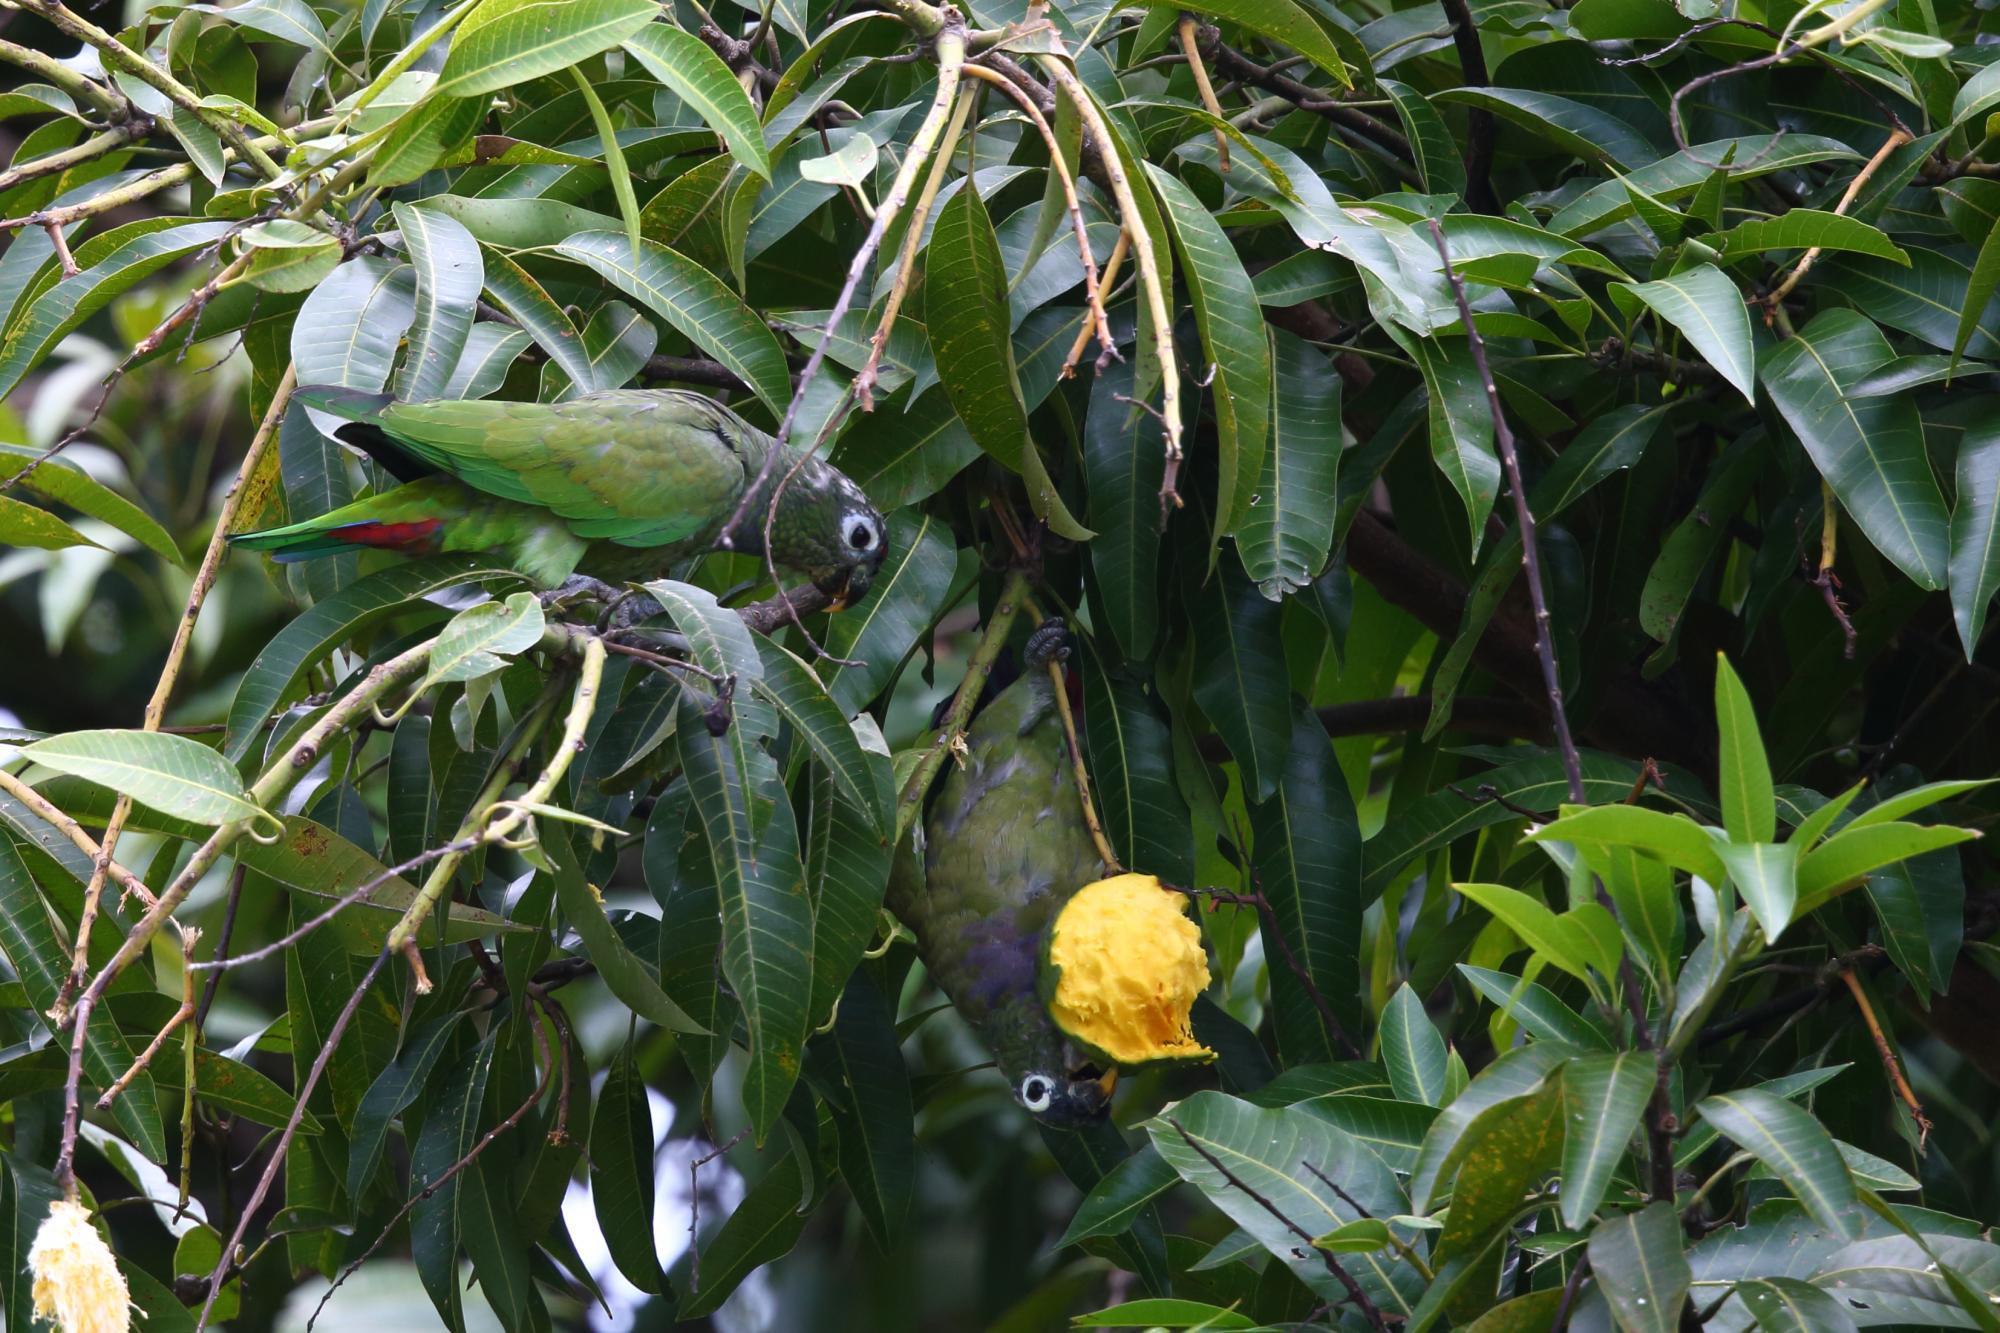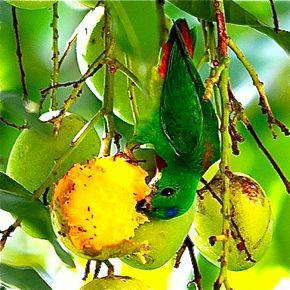The first image is the image on the left, the second image is the image on the right. Given the left and right images, does the statement "The right image shows a single toucan that has an orange beak and is upside down." hold true? Answer yes or no. No. The first image is the image on the left, the second image is the image on the right. Assess this claim about the two images: "In the image on the right, a lone parrot/parakeet eats fruit, while hanging upside-down.". Correct or not? Answer yes or no. Yes. 